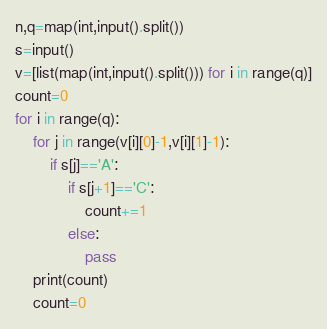Convert code to text. <code><loc_0><loc_0><loc_500><loc_500><_Python_>n,q=map(int,input().split())
s=input()
v=[list(map(int,input().split())) for i in range(q)]
count=0
for i in range(q):
    for j in range(v[i][0]-1,v[i][1]-1):
        if s[j]=='A':
            if s[j+1]=='C':
                count+=1
            else:
                pass
    print(count)
    count=0</code> 